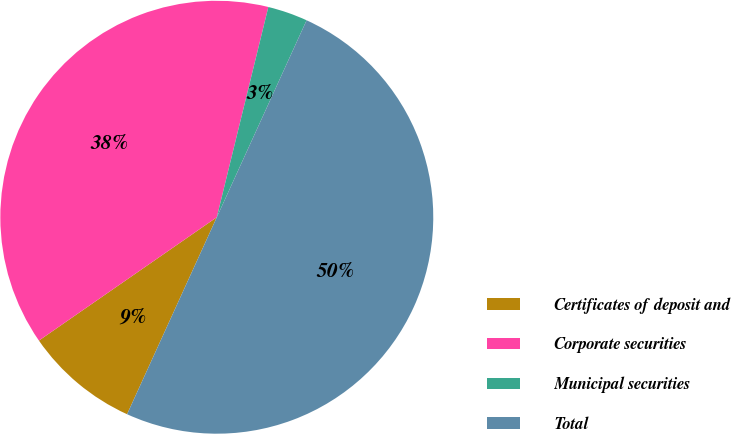Convert chart to OTSL. <chart><loc_0><loc_0><loc_500><loc_500><pie_chart><fcel>Certificates of deposit and<fcel>Corporate securities<fcel>Municipal securities<fcel>Total<nl><fcel>8.55%<fcel>38.48%<fcel>2.98%<fcel>50.0%<nl></chart> 